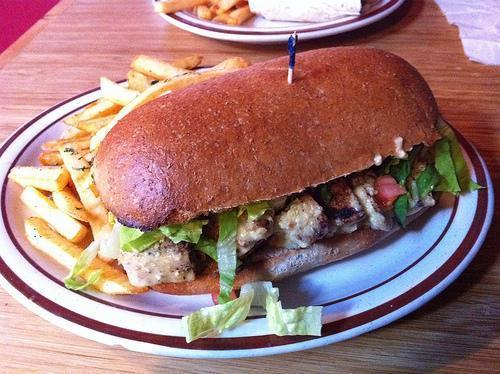How many toothpicks are in the picture?
Give a very brief answer. 1. 